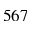<formula> <loc_0><loc_0><loc_500><loc_500>5 6 7</formula> 